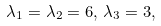Convert formula to latex. <formula><loc_0><loc_0><loc_500><loc_500>\lambda _ { 1 } = \lambda _ { 2 } = 6 , \, \lambda _ { 3 } = 3 ,</formula> 